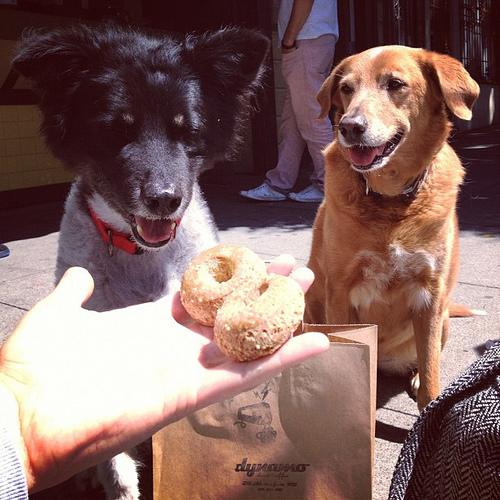Identify the type of clothing and accessories worn by the man in the image. The man is wearing a white shirt, brown pants, and white shoes, with a wristband on his hand in a pocket. Perform a complex reasoning task by explaining the possible relationship between the dogs, the man, and the treats. The man could be the owner of the two dogs, and the treats are being offered by someone else to the dogs as a way of engaging with them or rewarding them for good behavior. Based on the image, what could be the emotional state of the dogs? The dogs appear to be excited and focused on the treats, suggesting that they are in a happy and anticipative state. Provide a brief summary of the scene captured in the image. Two dogs are sitting on the sidewalk with a man walking behind them, while a hand holding two donuts and another holding dog treats are visible. The dogs are wearing red collars and looking at the treats. How many donuts are in the image and what are their colors? There are two tan donuts next to each other, held in a hand. Evaluate the image's overall quality and composition. The image has a clear and detailed composition with a wide range of objects and interactions, providing a high-quality visual representation. Describe any words or logos visible in the image and their context. The words "Dynamo" are written on a brown bag, which could be the name of a restaurant, as indicated by its logo. What are the colors and types of dogs in the image? The image has a light brown dog with a little white fur on its chest, and a black and gray dog, both with red collars. Analyze the interaction between the dogs and the treats in the image. Both dogs are attentively looking at the dog treats held in the outstretched hand, suggesting that they are interested in or waiting for the treats. Count and describe the main objects and living beings in the image There are two dogs with red collars, one man walking wearing white shoes, a hand holding two donuts, and another hand holding dog treats. 